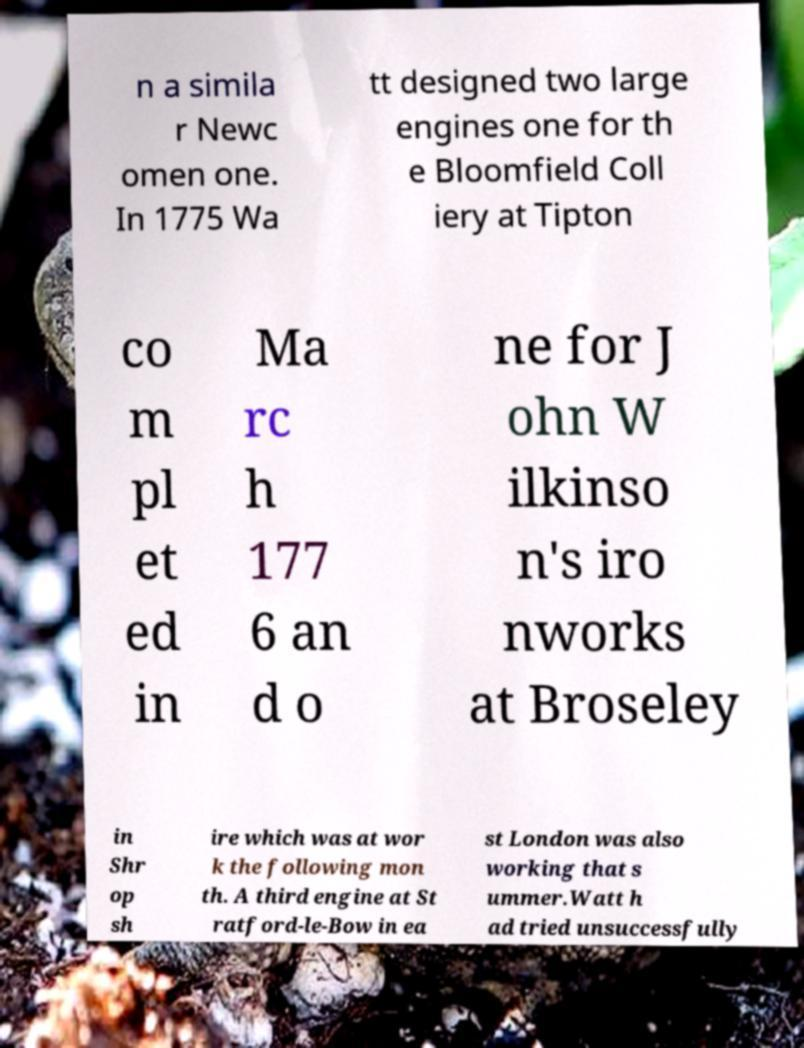Can you read and provide the text displayed in the image?This photo seems to have some interesting text. Can you extract and type it out for me? n a simila r Newc omen one. In 1775 Wa tt designed two large engines one for th e Bloomfield Coll iery at Tipton co m pl et ed in Ma rc h 177 6 an d o ne for J ohn W ilkinso n's iro nworks at Broseley in Shr op sh ire which was at wor k the following mon th. A third engine at St ratford-le-Bow in ea st London was also working that s ummer.Watt h ad tried unsuccessfully 